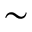Convert formula to latex. <formula><loc_0><loc_0><loc_500><loc_500>\sim</formula> 